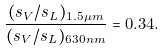Convert formula to latex. <formula><loc_0><loc_0><loc_500><loc_500>\frac { ( s _ { V } / s _ { L } ) _ { 1 . 5 \mu m } } { ( s _ { V } / s _ { L } ) _ { 6 3 0 n m } } = 0 . 3 4 .</formula> 